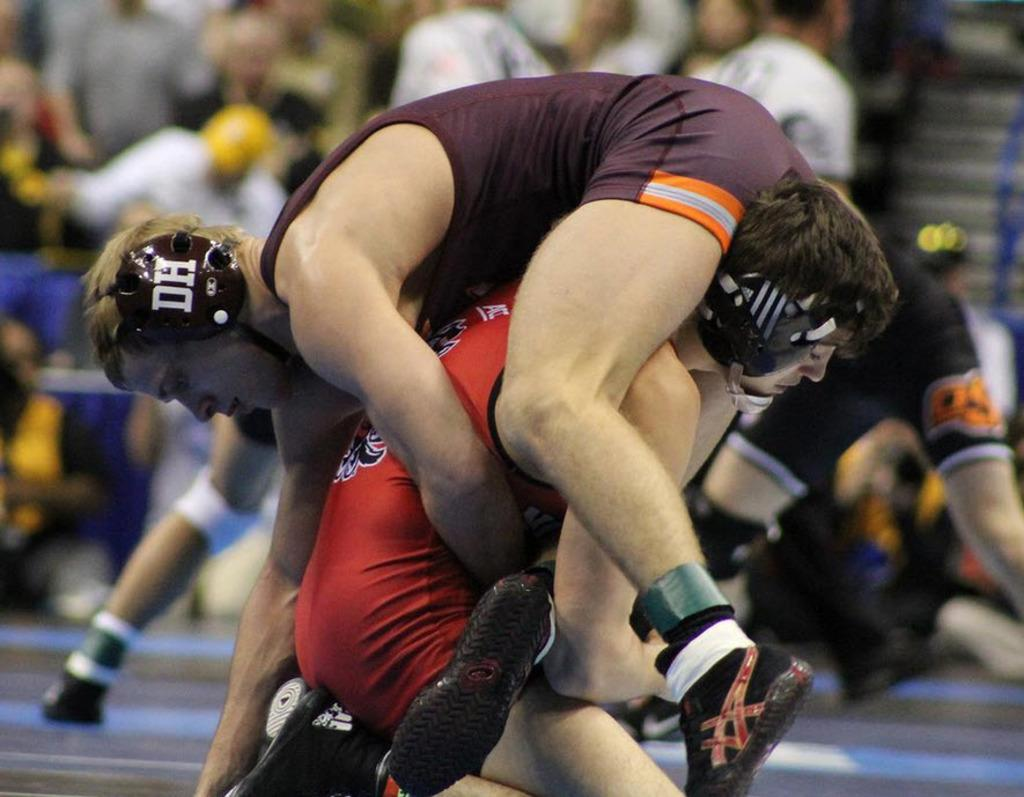Provide a one-sentence caption for the provided image. A wrestler wearing a DH headpiece is being lifted off the ground. 